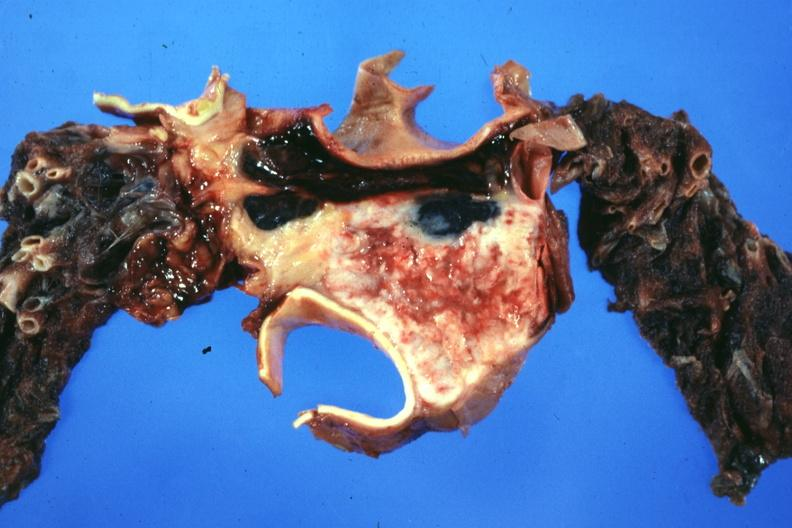s granulosa cell tumor present?
Answer the question using a single word or phrase. No 